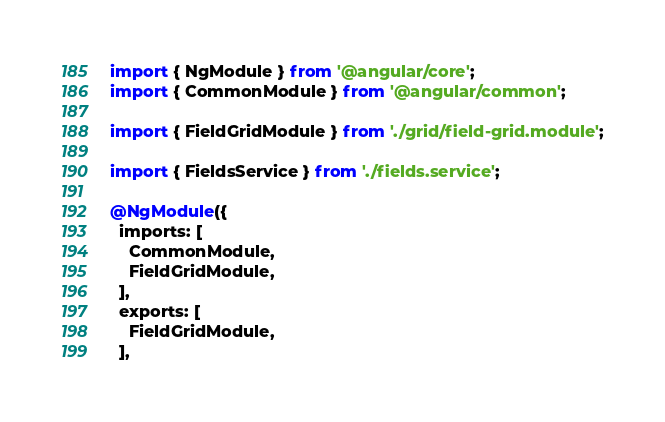Convert code to text. <code><loc_0><loc_0><loc_500><loc_500><_TypeScript_>import { NgModule } from '@angular/core';
import { CommonModule } from '@angular/common';

import { FieldGridModule } from './grid/field-grid.module';

import { FieldsService } from './fields.service';

@NgModule({
  imports: [
    CommonModule,
    FieldGridModule,
  ],
  exports: [
    FieldGridModule,
  ],</code> 